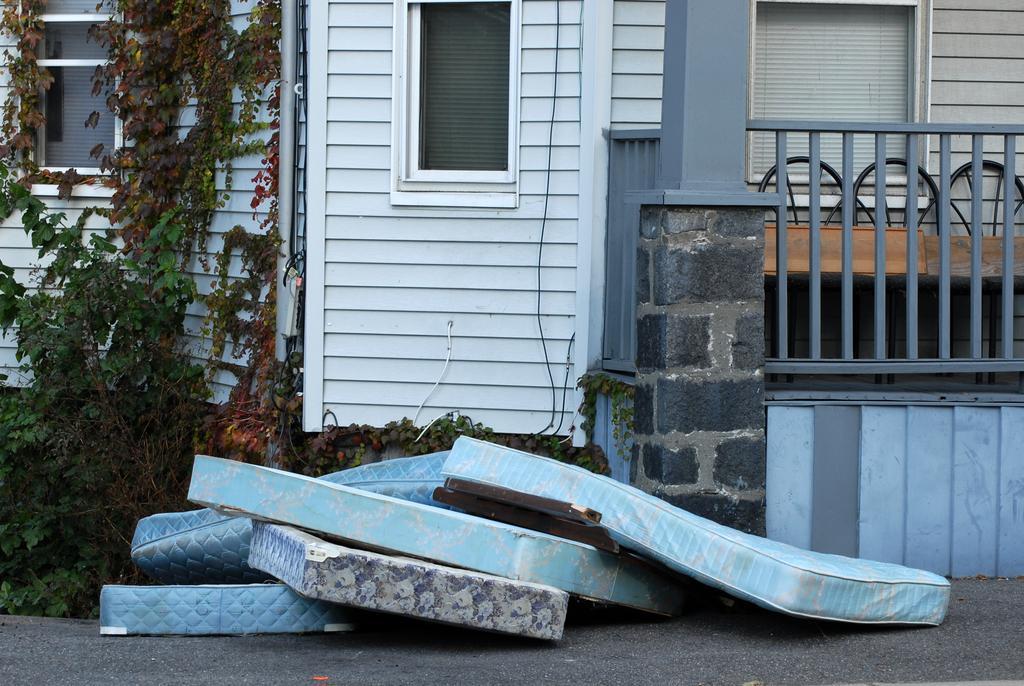How would you summarize this image in a sentence or two? In this image we can see one building with three windows and three chairs are there. One pipe and some wires are there. Some plants are there. In front of the building some objects are there and one road is there. 